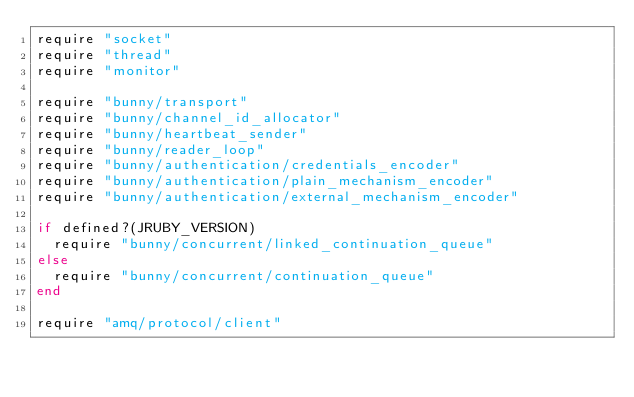<code> <loc_0><loc_0><loc_500><loc_500><_Ruby_>require "socket"
require "thread"
require "monitor"

require "bunny/transport"
require "bunny/channel_id_allocator"
require "bunny/heartbeat_sender"
require "bunny/reader_loop"
require "bunny/authentication/credentials_encoder"
require "bunny/authentication/plain_mechanism_encoder"
require "bunny/authentication/external_mechanism_encoder"

if defined?(JRUBY_VERSION)
  require "bunny/concurrent/linked_continuation_queue"
else
  require "bunny/concurrent/continuation_queue"
end

require "amq/protocol/client"</code> 